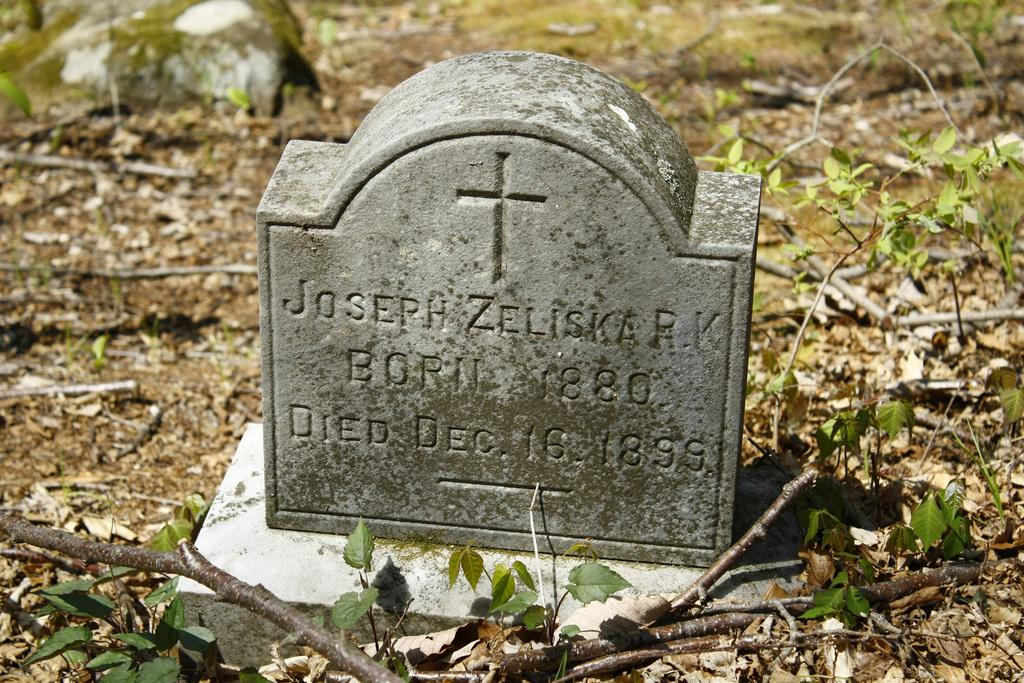What is the main subject of the image? There is a memorial stone in the image. What can be seen in the background of the image? There are leaves in the background of the image. How many babies are present at the memorial stone in the image? There are no babies present in the image; it features a memorial stone and leaves in the background. 